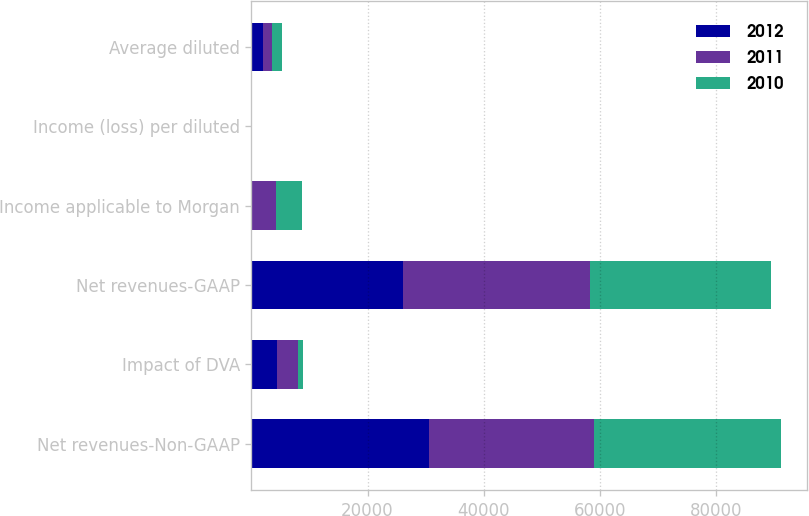Convert chart to OTSL. <chart><loc_0><loc_0><loc_500><loc_500><stacked_bar_chart><ecel><fcel>Net revenues-Non-GAAP<fcel>Impact of DVA<fcel>Net revenues-GAAP<fcel>Income applicable to Morgan<fcel>Income (loss) per diluted<fcel>Average diluted<nl><fcel>2012<fcel>30514<fcel>4402<fcel>26112<fcel>135<fcel>0.02<fcel>1919<nl><fcel>2011<fcel>28555<fcel>3681<fcel>32236<fcel>4161<fcel>1.26<fcel>1655<nl><fcel>2010<fcel>32103<fcel>873<fcel>31230<fcel>4469<fcel>2.45<fcel>1722<nl></chart> 